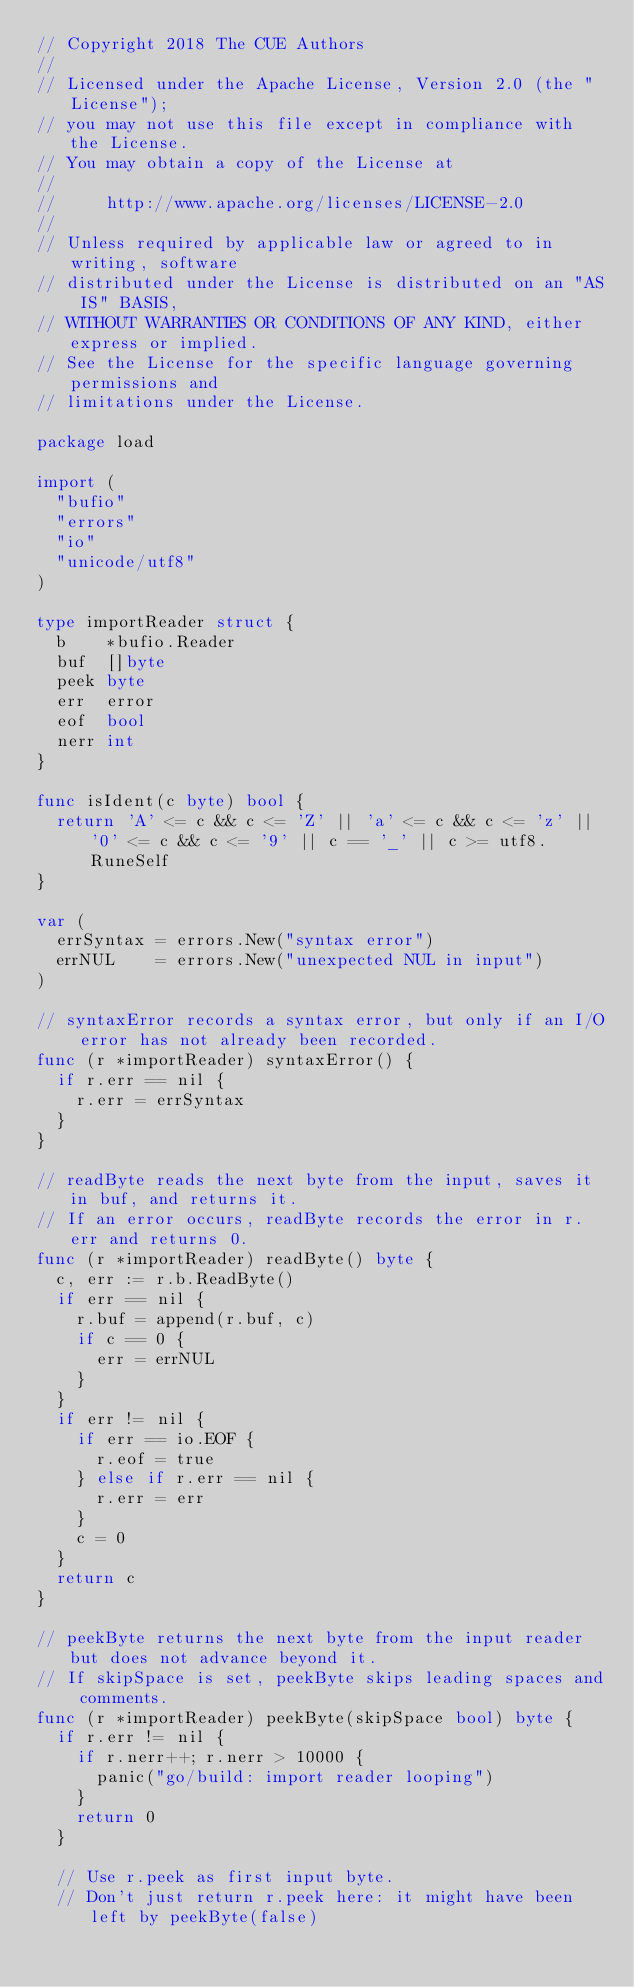<code> <loc_0><loc_0><loc_500><loc_500><_Go_>// Copyright 2018 The CUE Authors
//
// Licensed under the Apache License, Version 2.0 (the "License");
// you may not use this file except in compliance with the License.
// You may obtain a copy of the License at
//
//     http://www.apache.org/licenses/LICENSE-2.0
//
// Unless required by applicable law or agreed to in writing, software
// distributed under the License is distributed on an "AS IS" BASIS,
// WITHOUT WARRANTIES OR CONDITIONS OF ANY KIND, either express or implied.
// See the License for the specific language governing permissions and
// limitations under the License.

package load

import (
	"bufio"
	"errors"
	"io"
	"unicode/utf8"
)

type importReader struct {
	b    *bufio.Reader
	buf  []byte
	peek byte
	err  error
	eof  bool
	nerr int
}

func isIdent(c byte) bool {
	return 'A' <= c && c <= 'Z' || 'a' <= c && c <= 'z' || '0' <= c && c <= '9' || c == '_' || c >= utf8.RuneSelf
}

var (
	errSyntax = errors.New("syntax error")
	errNUL    = errors.New("unexpected NUL in input")
)

// syntaxError records a syntax error, but only if an I/O error has not already been recorded.
func (r *importReader) syntaxError() {
	if r.err == nil {
		r.err = errSyntax
	}
}

// readByte reads the next byte from the input, saves it in buf, and returns it.
// If an error occurs, readByte records the error in r.err and returns 0.
func (r *importReader) readByte() byte {
	c, err := r.b.ReadByte()
	if err == nil {
		r.buf = append(r.buf, c)
		if c == 0 {
			err = errNUL
		}
	}
	if err != nil {
		if err == io.EOF {
			r.eof = true
		} else if r.err == nil {
			r.err = err
		}
		c = 0
	}
	return c
}

// peekByte returns the next byte from the input reader but does not advance beyond it.
// If skipSpace is set, peekByte skips leading spaces and comments.
func (r *importReader) peekByte(skipSpace bool) byte {
	if r.err != nil {
		if r.nerr++; r.nerr > 10000 {
			panic("go/build: import reader looping")
		}
		return 0
	}

	// Use r.peek as first input byte.
	// Don't just return r.peek here: it might have been left by peekByte(false)</code> 